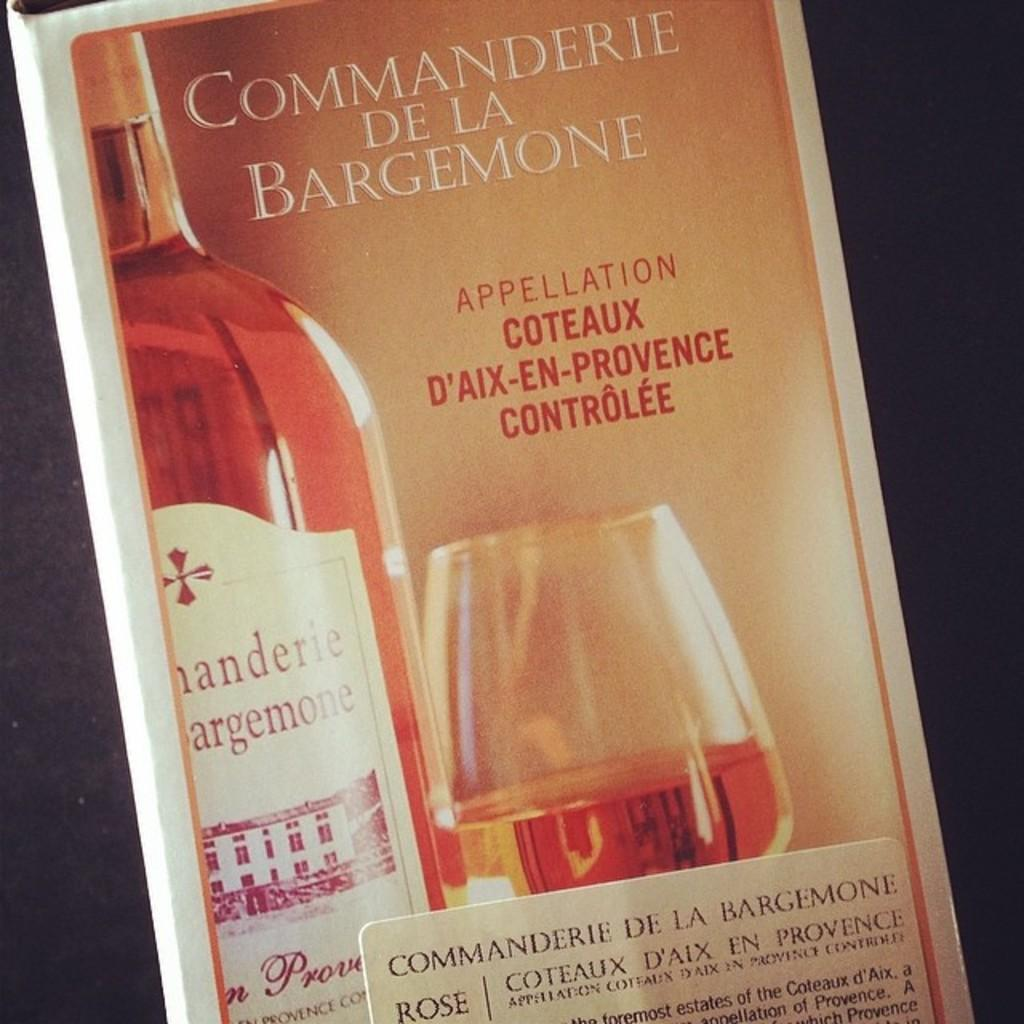<image>
Describe the image concisely. A box of wine called Commanderie De La Bargemone. 